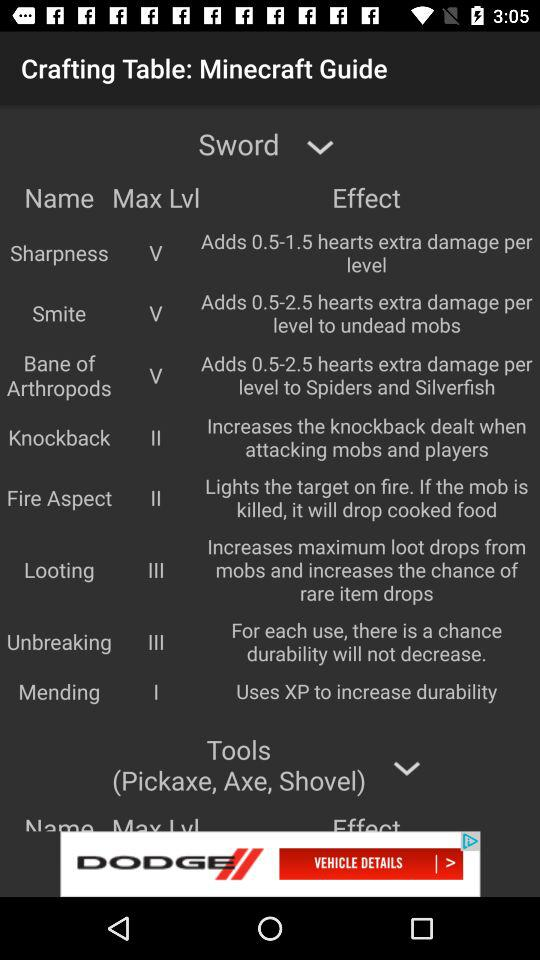What is the effect of looting? The effect of looting is "Increases maximum loot drops from mobs and increases the chance of rare item drops". 